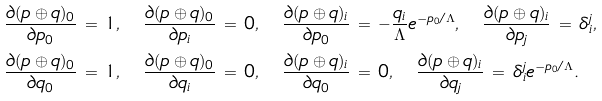<formula> <loc_0><loc_0><loc_500><loc_500>& \frac { \partial ( p \oplus q ) _ { 0 } } { \partial p _ { 0 } } \, = \, 1 , \quad \frac { \partial ( p \oplus q ) _ { 0 } } { \partial p _ { i } } \, = \, 0 , \quad \frac { \partial ( p \oplus q ) _ { i } } { \partial p _ { 0 } } \, = \, - \frac { q _ { i } } { \Lambda } e ^ { - p _ { 0 } / \Lambda } , \quad \frac { \partial ( p \oplus q ) _ { i } } { \partial p _ { j } } \, = \, \delta _ { i } ^ { j } , \\ & \frac { \partial ( p \oplus q ) _ { 0 } } { \partial q _ { 0 } } \, = \, 1 , \quad \frac { \partial ( p \oplus q ) _ { 0 } } { \partial q _ { i } } \, = \, 0 , \quad \frac { \partial ( p \oplus q ) _ { i } } { \partial q _ { 0 } } \, = \, 0 , \quad \frac { \partial ( p \oplus q ) _ { i } } { \partial q _ { j } } \, = \, \delta _ { i } ^ { j } e ^ { - p _ { 0 } / \Lambda } .</formula> 